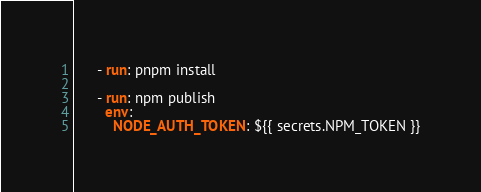Convert code to text. <code><loc_0><loc_0><loc_500><loc_500><_YAML_>
      - run: pnpm install

      - run: npm publish
        env:
          NODE_AUTH_TOKEN: ${{ secrets.NPM_TOKEN }}
</code> 